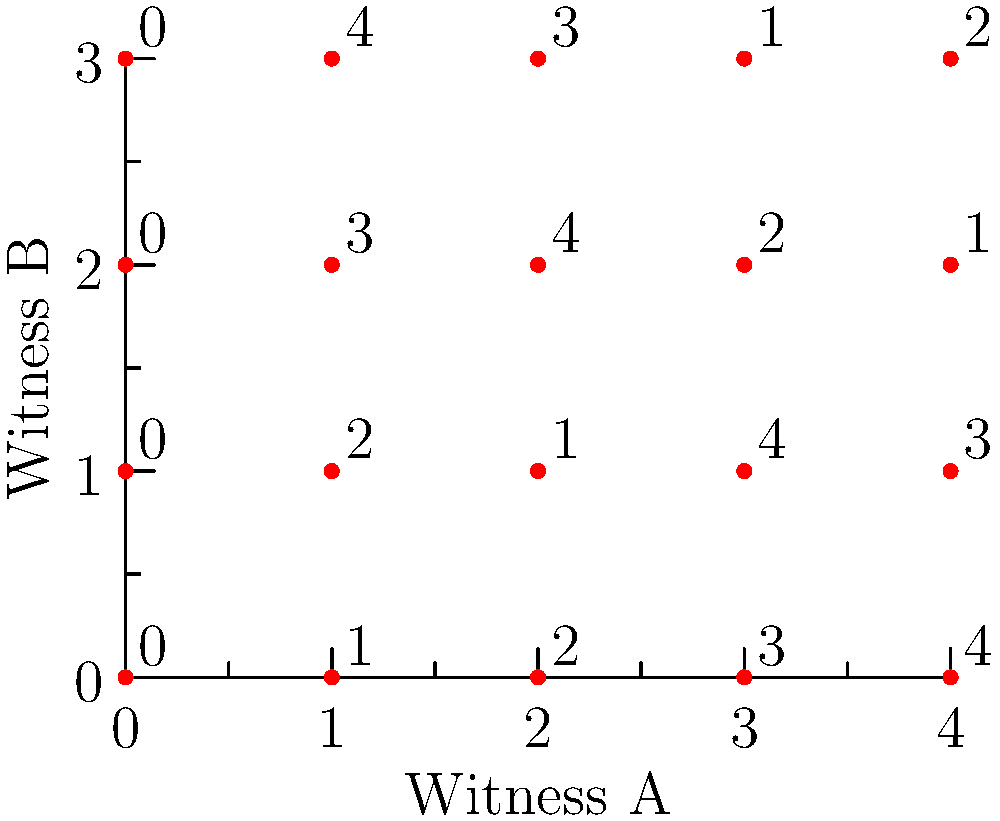In a case involving multiple witness testimonies, you need to align their accounts on a single grid. Witness A's coordinates are given as (x, y), while Witness B's coordinates are (y, x). The grid above shows the original data points. If you apply the transformation $T(x, y) = (y, x)$ to Witness A's coordinates, what will be the new coordinates of the point originally at (3, 4)? To solve this problem, we need to follow these steps:

1. Identify the original point: The question asks about the point originally at (3, 4).

2. Understand the transformation: The transformation $T(x, y) = (y, x)$ swaps the x and y coordinates.

3. Apply the transformation:
   - Original point: (3, 4)
   - After transformation: (4, 3)

4. Verify on the grid:
   - In the original grid, the point (3, 4) corresponds to the value 2.
   - After transformation, we should look at (4, 3), which indeed corresponds to the value 2.

This transformation effectively aligns Witness A's account with Witness B's perspective, making it easier to compare their testimonies on a single grid.
Answer: (4, 3) 